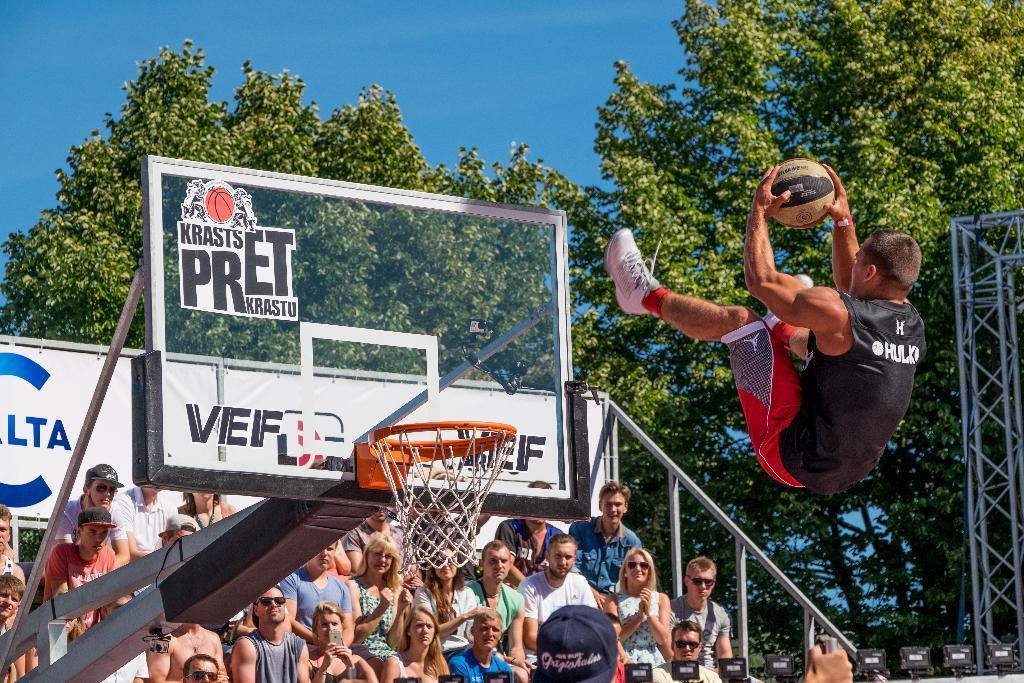Can you describe this image briefly? On the right side of the image we can see a man jumping and holding a ball. On the left we can see a basketball hoop and a board. At the bottom there are people sitting. In the background there are trees, pole and sky. 